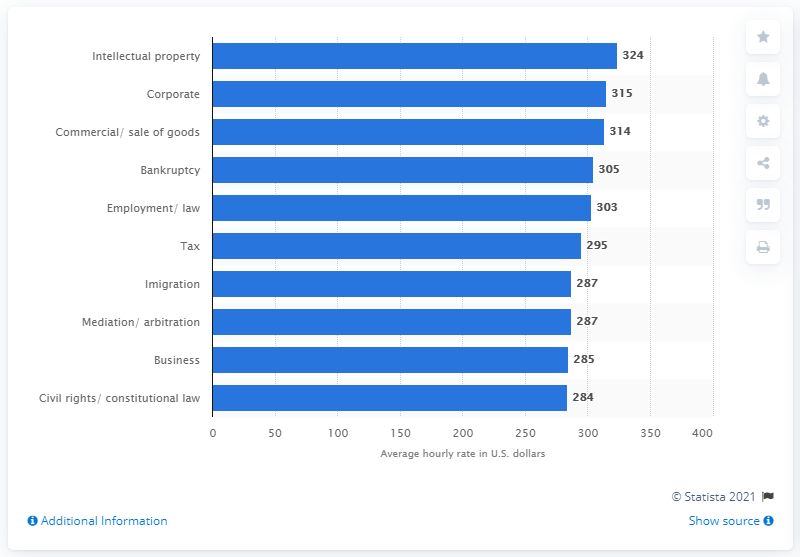Specify some key components in this picture. The average hourly rate of intellectual property law firms in the U.S. in 2020 was 324. 